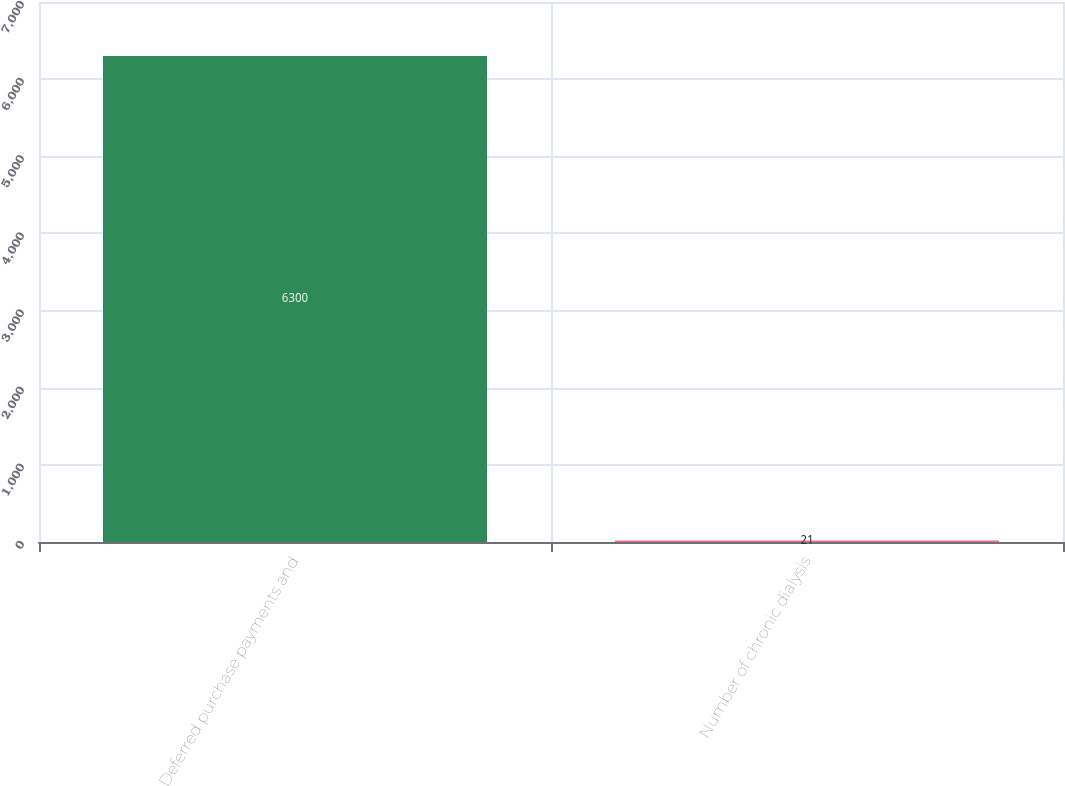Convert chart to OTSL. <chart><loc_0><loc_0><loc_500><loc_500><bar_chart><fcel>Deferred purchase payments and<fcel>Number of chronic dialysis<nl><fcel>6300<fcel>21<nl></chart> 